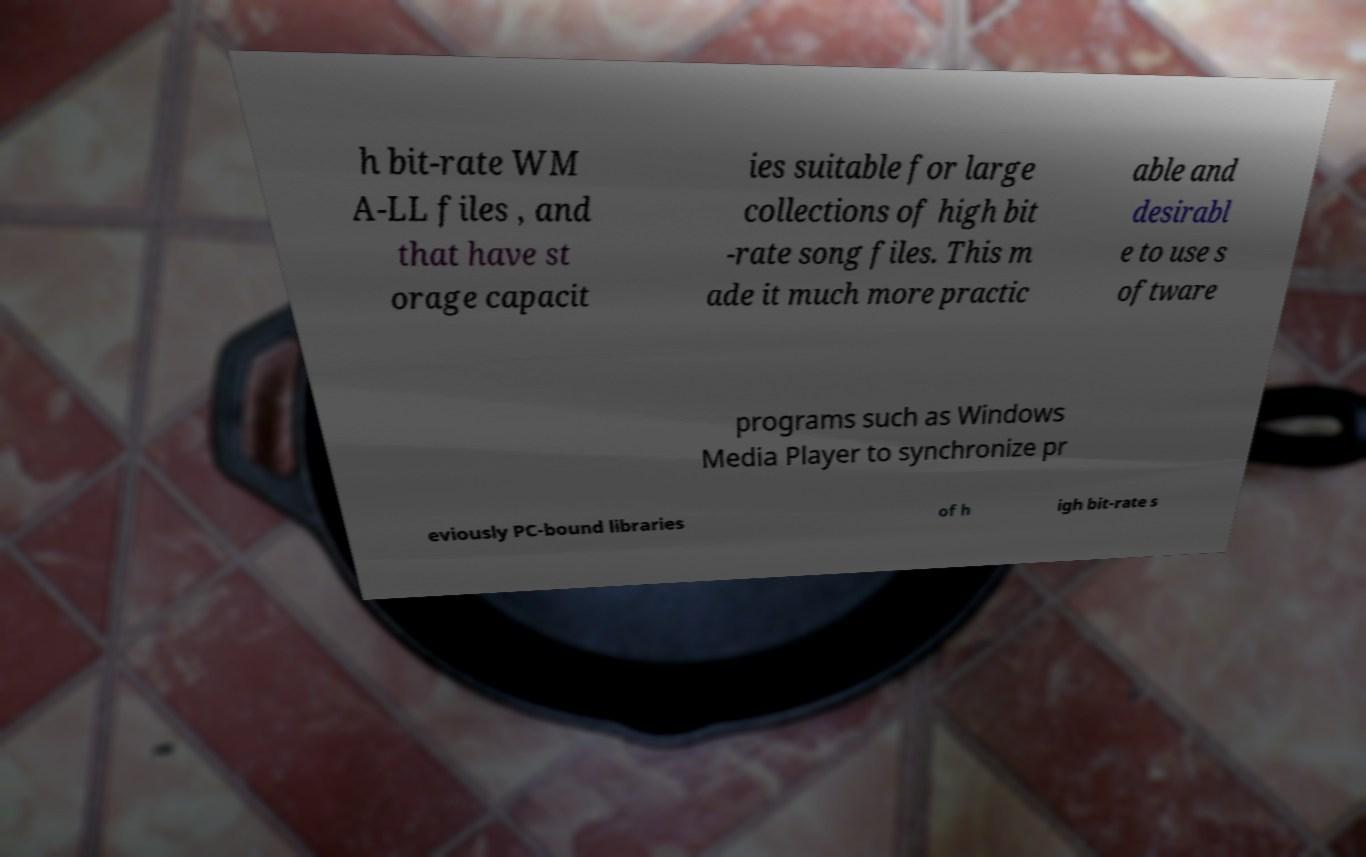Can you accurately transcribe the text from the provided image for me? h bit-rate WM A-LL files , and that have st orage capacit ies suitable for large collections of high bit -rate song files. This m ade it much more practic able and desirabl e to use s oftware programs such as Windows Media Player to synchronize pr eviously PC-bound libraries of h igh bit-rate s 